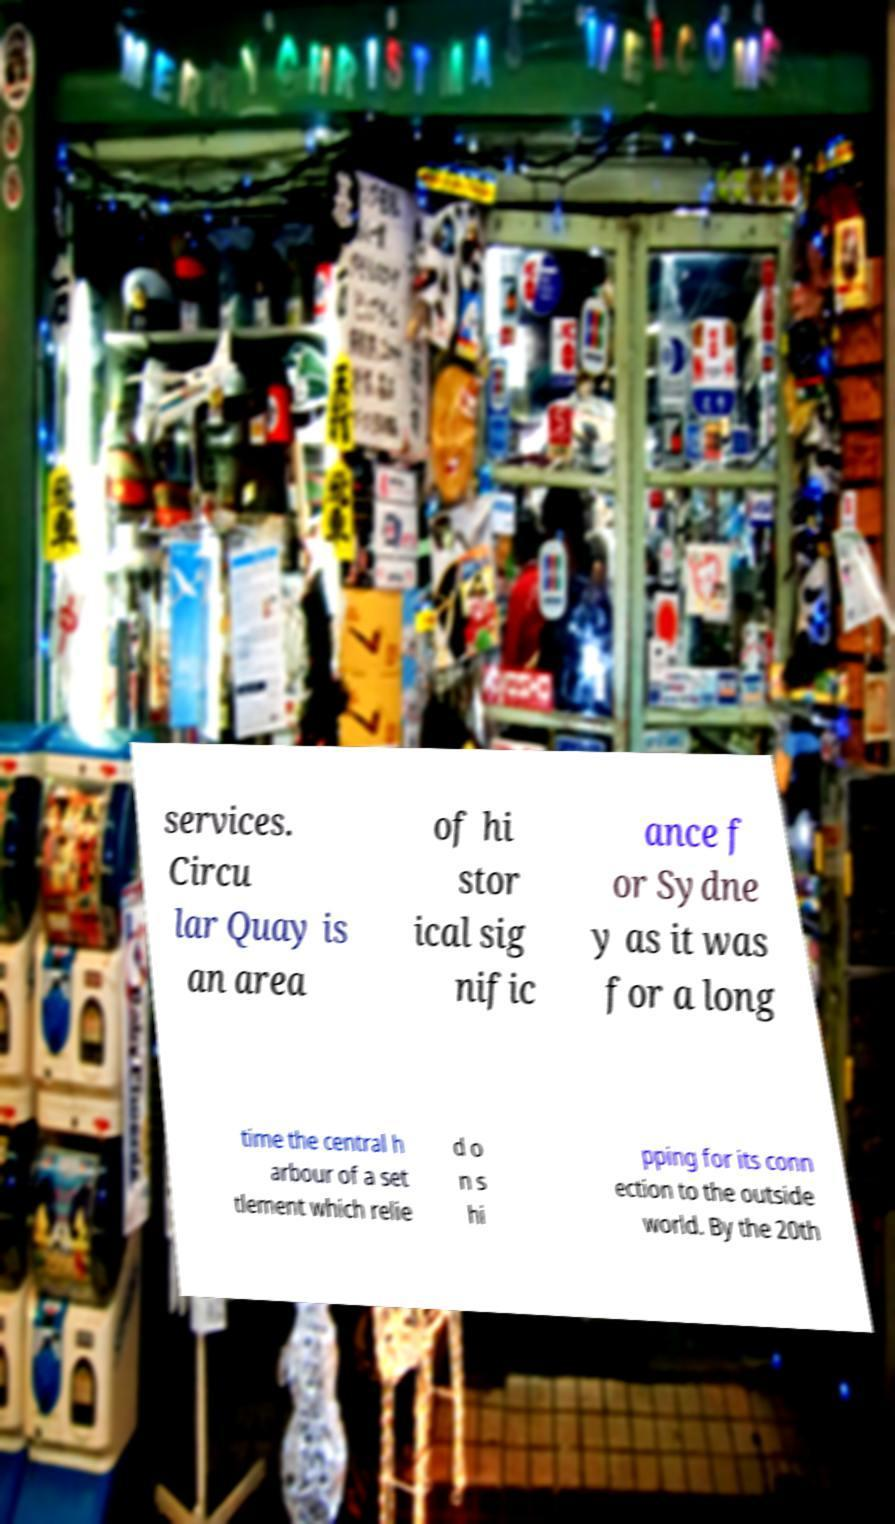Could you extract and type out the text from this image? services. Circu lar Quay is an area of hi stor ical sig nific ance f or Sydne y as it was for a long time the central h arbour of a set tlement which relie d o n s hi pping for its conn ection to the outside world. By the 20th 